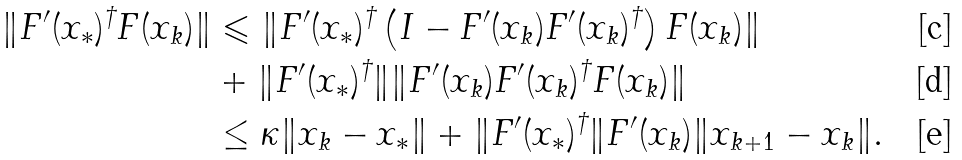<formula> <loc_0><loc_0><loc_500><loc_500>\| F ^ { \prime } ( x _ { * } ) ^ { \dagger } F ( x _ { k } ) \| & \leqslant \| F ^ { \prime } ( x _ { * } ) ^ { \dagger } \left ( I - F ^ { \prime } ( x _ { k } ) F ^ { \prime } ( x _ { k } ) ^ { \dagger } \right ) F ( x _ { k } ) \| \\ & + \| F ^ { \prime } ( x _ { * } ) ^ { \dagger } \| \| F ^ { \prime } ( x _ { k } ) F ^ { \prime } ( x _ { k } ) ^ { \dagger } F ( x _ { k } ) \| \\ & \leq \kappa \| x _ { k } - x _ { * } \| + \| F ^ { \prime } ( x _ { * } ) ^ { \dagger } \| F ^ { \prime } ( x _ { k } ) \| x _ { k + 1 } - x _ { k } \| .</formula> 